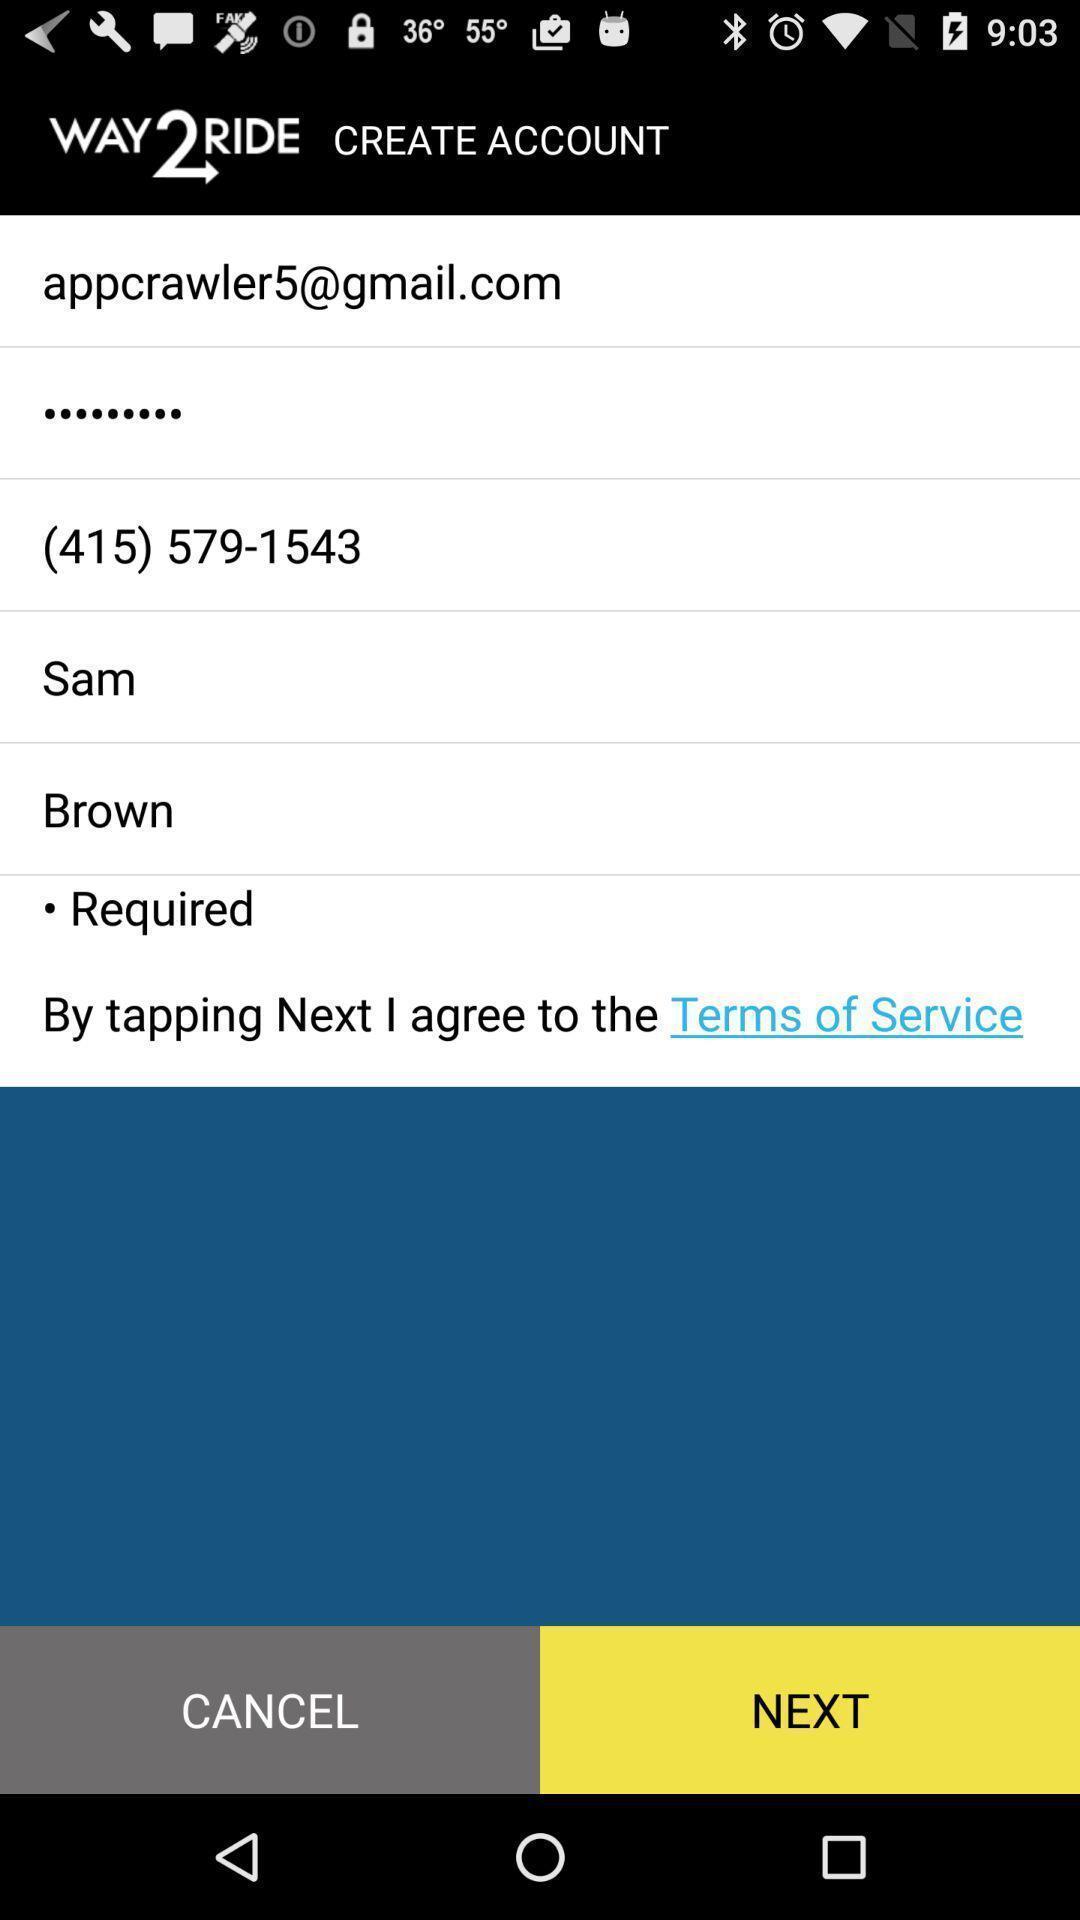Tell me about the visual elements in this screen capture. Page displaying the profile details with few options. 